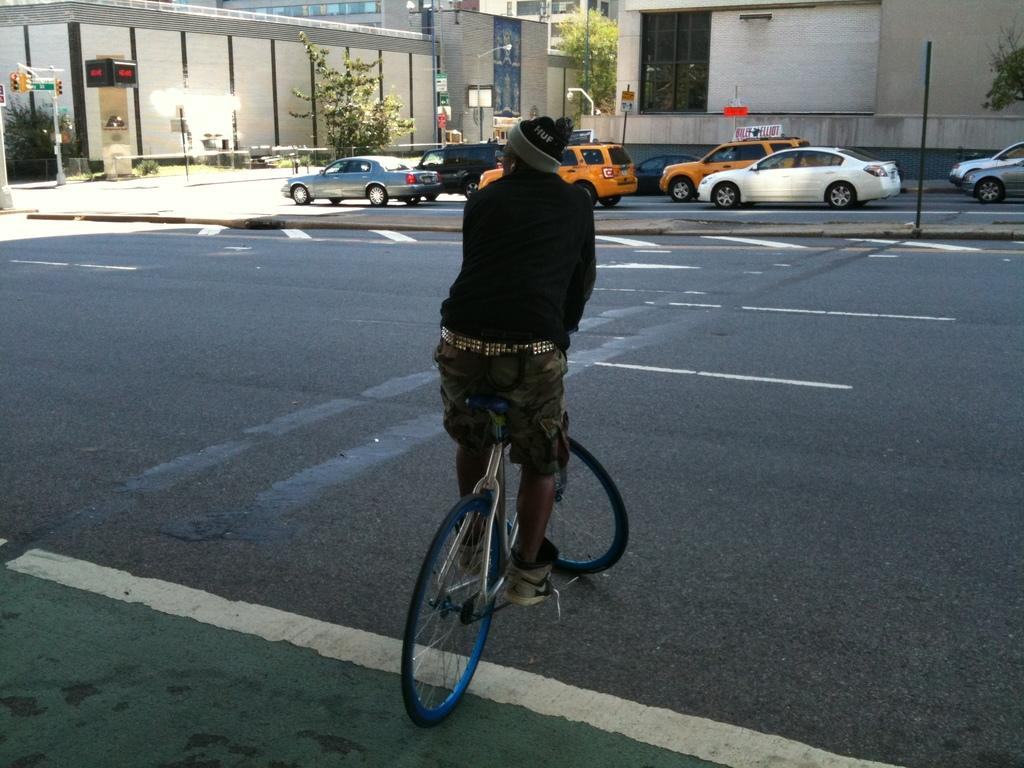What is the main subject of the image? There is a person on a bicycle in the image. What can be seen in the background of the image? There are vehicles, poles, traffic lights, trees, and buildings in the background of the image. What might be used to control traffic in the image? Traffic lights are present in the background of the image. What type of suit is the person on the bicycle wearing in the image? There is no suit visible in the image; the person on the bicycle is not wearing any clothing mentioned in the provided facts. 